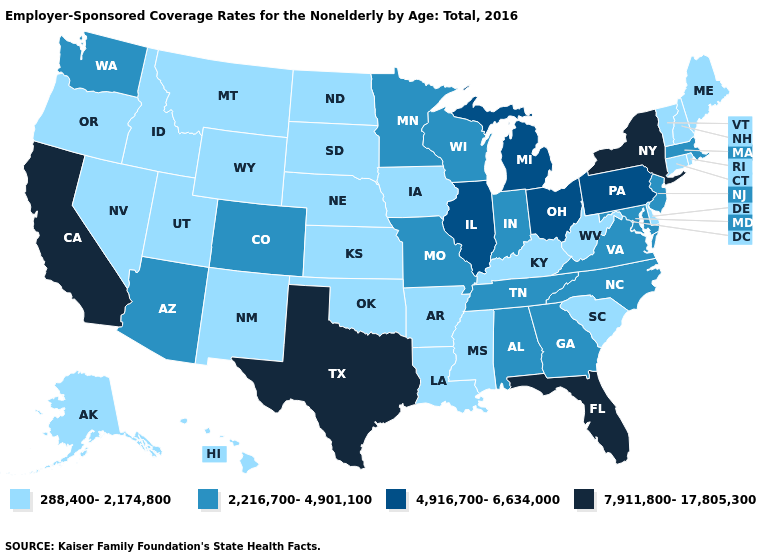What is the value of North Carolina?
Concise answer only. 2,216,700-4,901,100. Among the states that border Delaware , does New Jersey have the lowest value?
Write a very short answer. Yes. Does Alabama have a lower value than Michigan?
Give a very brief answer. Yes. Name the states that have a value in the range 4,916,700-6,634,000?
Quick response, please. Illinois, Michigan, Ohio, Pennsylvania. Does Utah have a higher value than Rhode Island?
Give a very brief answer. No. What is the highest value in the West ?
Quick response, please. 7,911,800-17,805,300. Name the states that have a value in the range 2,216,700-4,901,100?
Quick response, please. Alabama, Arizona, Colorado, Georgia, Indiana, Maryland, Massachusetts, Minnesota, Missouri, New Jersey, North Carolina, Tennessee, Virginia, Washington, Wisconsin. What is the lowest value in the USA?
Short answer required. 288,400-2,174,800. Among the states that border South Dakota , does North Dakota have the highest value?
Answer briefly. No. Is the legend a continuous bar?
Quick response, please. No. Does Kentucky have the highest value in the USA?
Answer briefly. No. Is the legend a continuous bar?
Quick response, please. No. Does Indiana have the lowest value in the USA?
Be succinct. No. What is the value of West Virginia?
Give a very brief answer. 288,400-2,174,800. Does Colorado have the lowest value in the USA?
Concise answer only. No. 